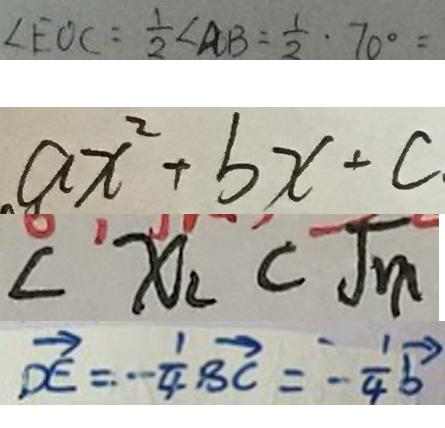Convert formula to latex. <formula><loc_0><loc_0><loc_500><loc_500>\angle E O C = \frac { 1 } { 2 } \angle A B = \frac { 1 } { 2 } \cdot 7 0 ^ { \circ } = 
 a x ^ { 2 } + b x + c 
 < x _ { 2 } < \sqrt { m } 
 \overrightarrow { D E } = - \frac { 1 } { 4 } \overrightarrow { B C } = - \frac { 1 } { 4 } \overrightarrow { b }</formula> 